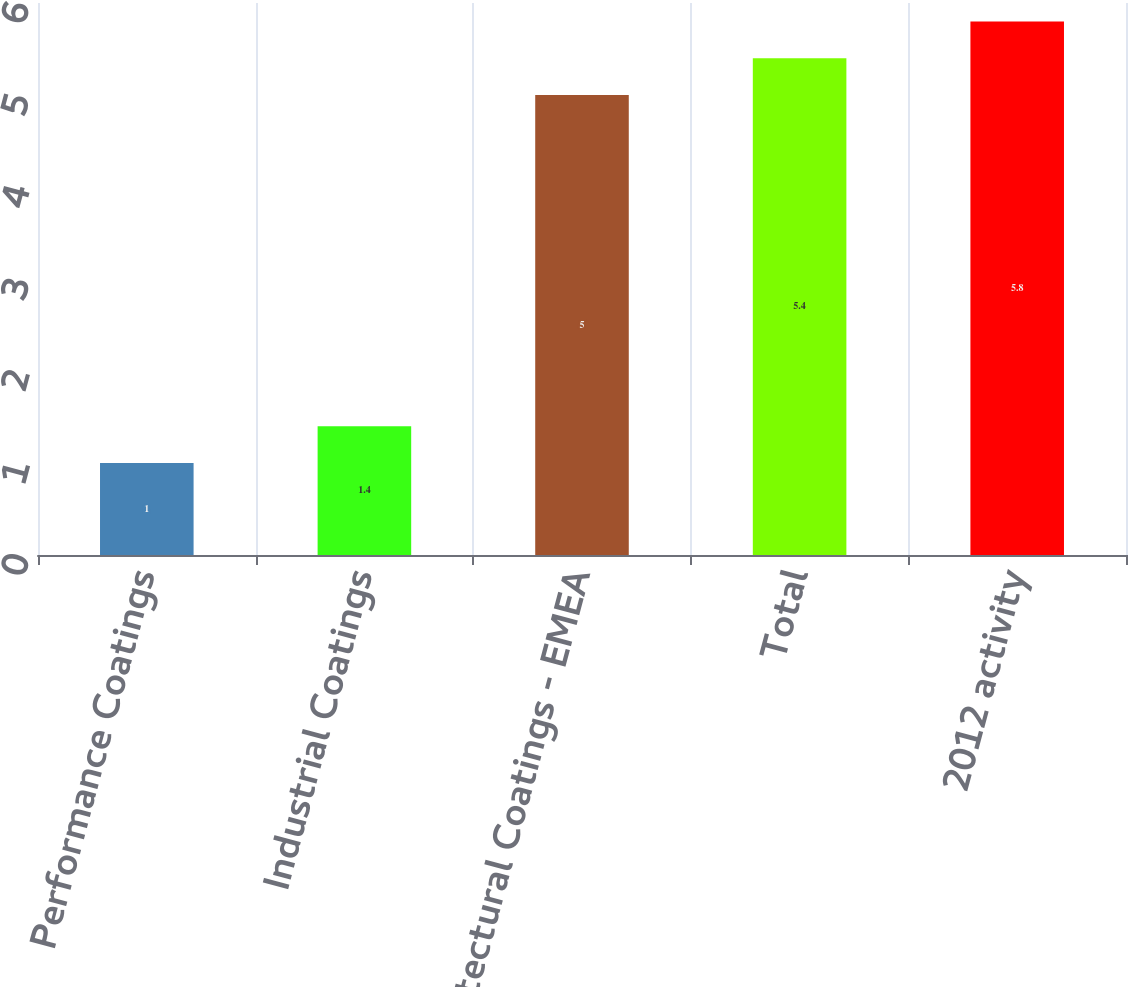<chart> <loc_0><loc_0><loc_500><loc_500><bar_chart><fcel>Performance Coatings<fcel>Industrial Coatings<fcel>Architectural Coatings - EMEA<fcel>Total<fcel>2012 activity<nl><fcel>1<fcel>1.4<fcel>5<fcel>5.4<fcel>5.8<nl></chart> 